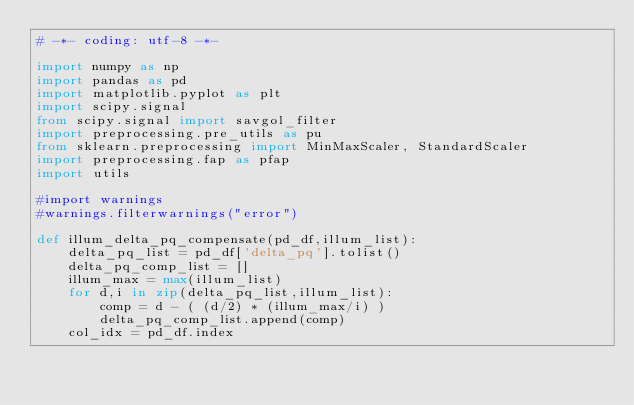<code> <loc_0><loc_0><loc_500><loc_500><_Python_># -*- coding: utf-8 -*-

import numpy as np
import pandas as pd
import matplotlib.pyplot as plt
import scipy.signal
from scipy.signal import savgol_filter
import preprocessing.pre_utils as pu
from sklearn.preprocessing import MinMaxScaler, StandardScaler
import preprocessing.fap as pfap
import utils

#import warnings
#warnings.filterwarnings("error")

def illum_delta_pq_compensate(pd_df,illum_list):
    delta_pq_list = pd_df['delta_pq'].tolist()
    delta_pq_comp_list = []
    illum_max = max(illum_list)
    for d,i in zip(delta_pq_list,illum_list):
        comp = d - ( (d/2) * (illum_max/i) )
        delta_pq_comp_list.append(comp)
    col_idx = pd_df.index</code> 